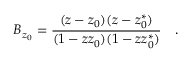Convert formula to latex. <formula><loc_0><loc_0><loc_500><loc_500>B _ { z _ { 0 } } = \frac { ( z - z _ { 0 } ) ( z - z _ { 0 } ^ { * } ) } { ( 1 - z z _ { 0 } ) ( 1 - z z _ { 0 } ^ { * } ) } \quad .</formula> 